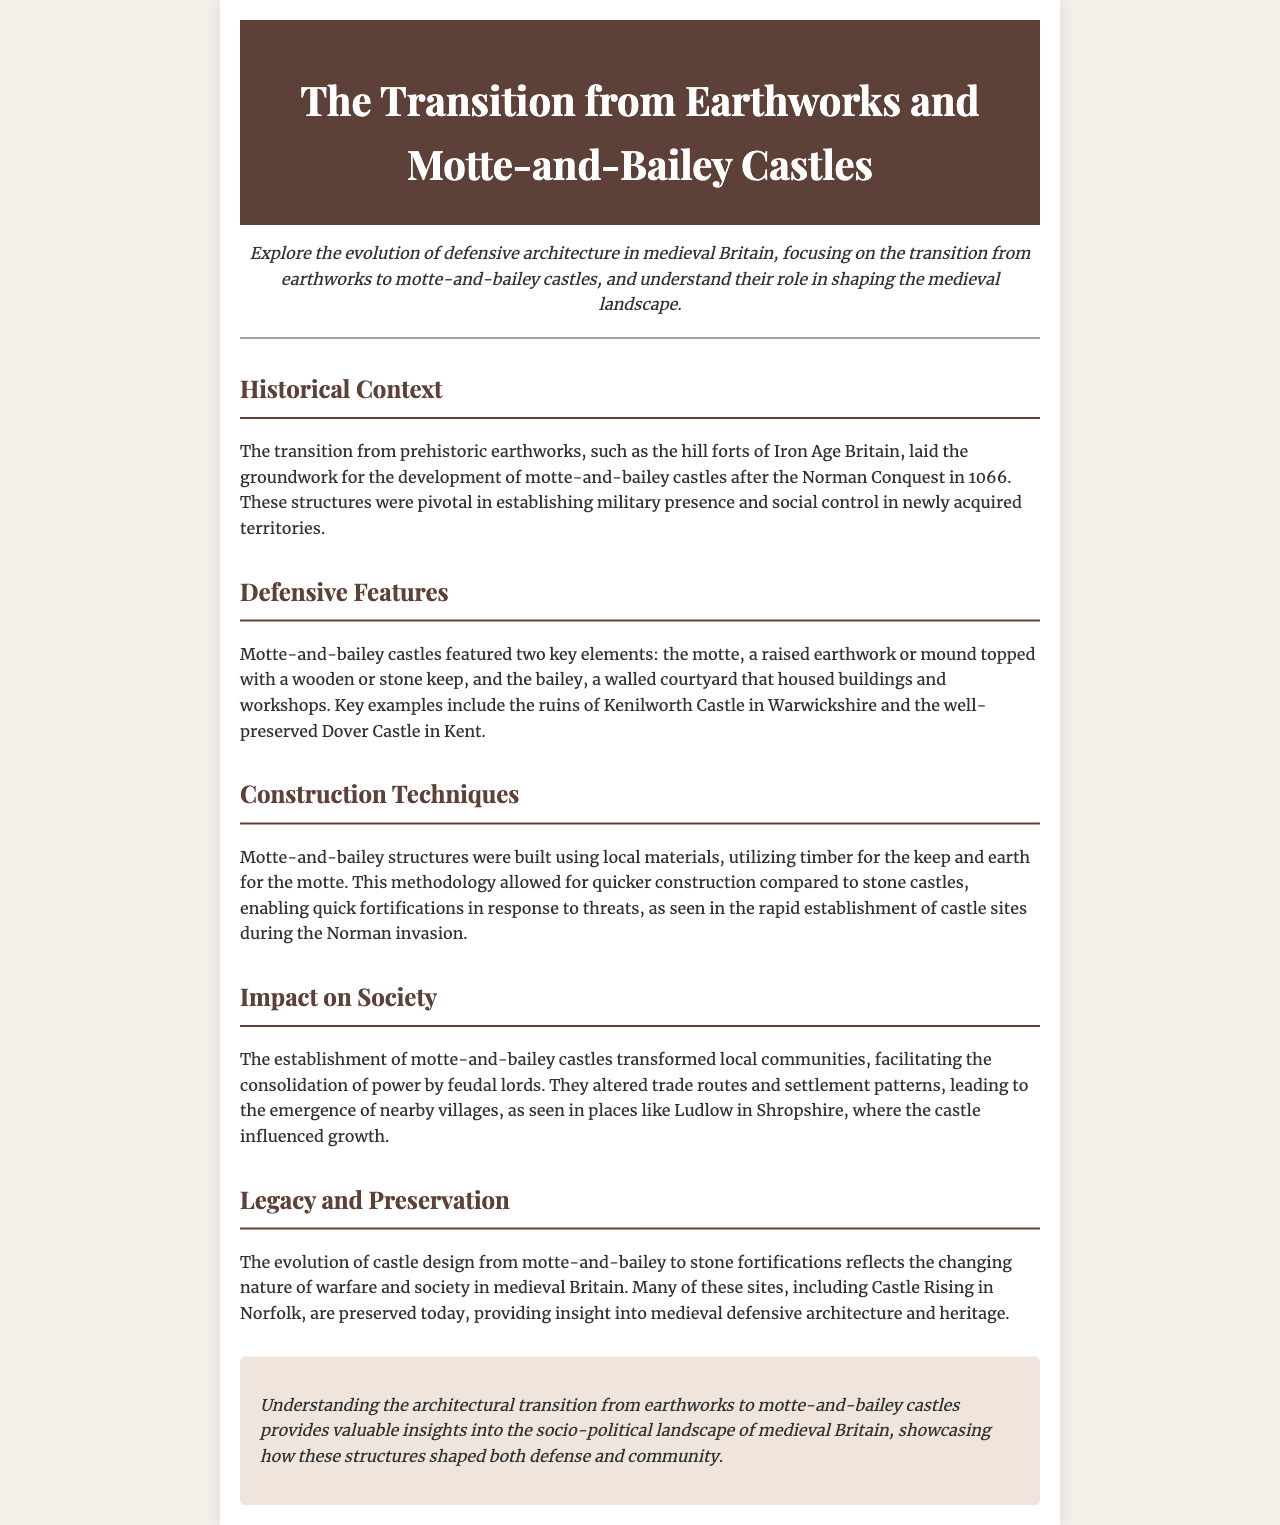What was the transitional structure following prehistoric earthworks? The transitional structure after prehistoric earthworks was the motte-and-bailey castle, introduced after the Norman Conquest in 1066.
Answer: motte-and-bailey castle What two key elements characterize motte-and-bailey castles? The two key elements of motte-and-bailey castles are the motte and the bailey.
Answer: motte and bailey Which castle is mentioned as a well-preserved example of motte-and-bailey architecture? Dover Castle in Kent is noted as a well-preserved example of motte-and-bailey architecture.
Answer: Dover Castle What material was primarily used for constructing the motte? The motte was constructed primarily using earth.
Answer: earth How did motte-and-bailey castles impact local communities? Motte-and-bailey castles transformed local communities by facilitating the consolidation of power by feudal lords.
Answer: consolidation of power What does the evolution from motte-and-bailey to stone fortifications reflect? The evolution from motte-and-bailey to stone fortifications reflects the changing nature of warfare and society in medieval Britain.
Answer: changing nature of warfare and society What site is given as an example of a preserved motte-and-bailey castle? Castle Rising in Norfolk is provided as an example of a preserved site.
Answer: Castle Rising What construction technique allowed for quicker building of motte-and-bailey castles? The use of local materials allowed for quicker construction of motte-and-bailey castles.
Answer: local materials How did motte-and-bailey castles influence trade routes? Motte-and-bailey castles altered trade routes and settlement patterns in local regions.
Answer: altered trade routes and settlement patterns 